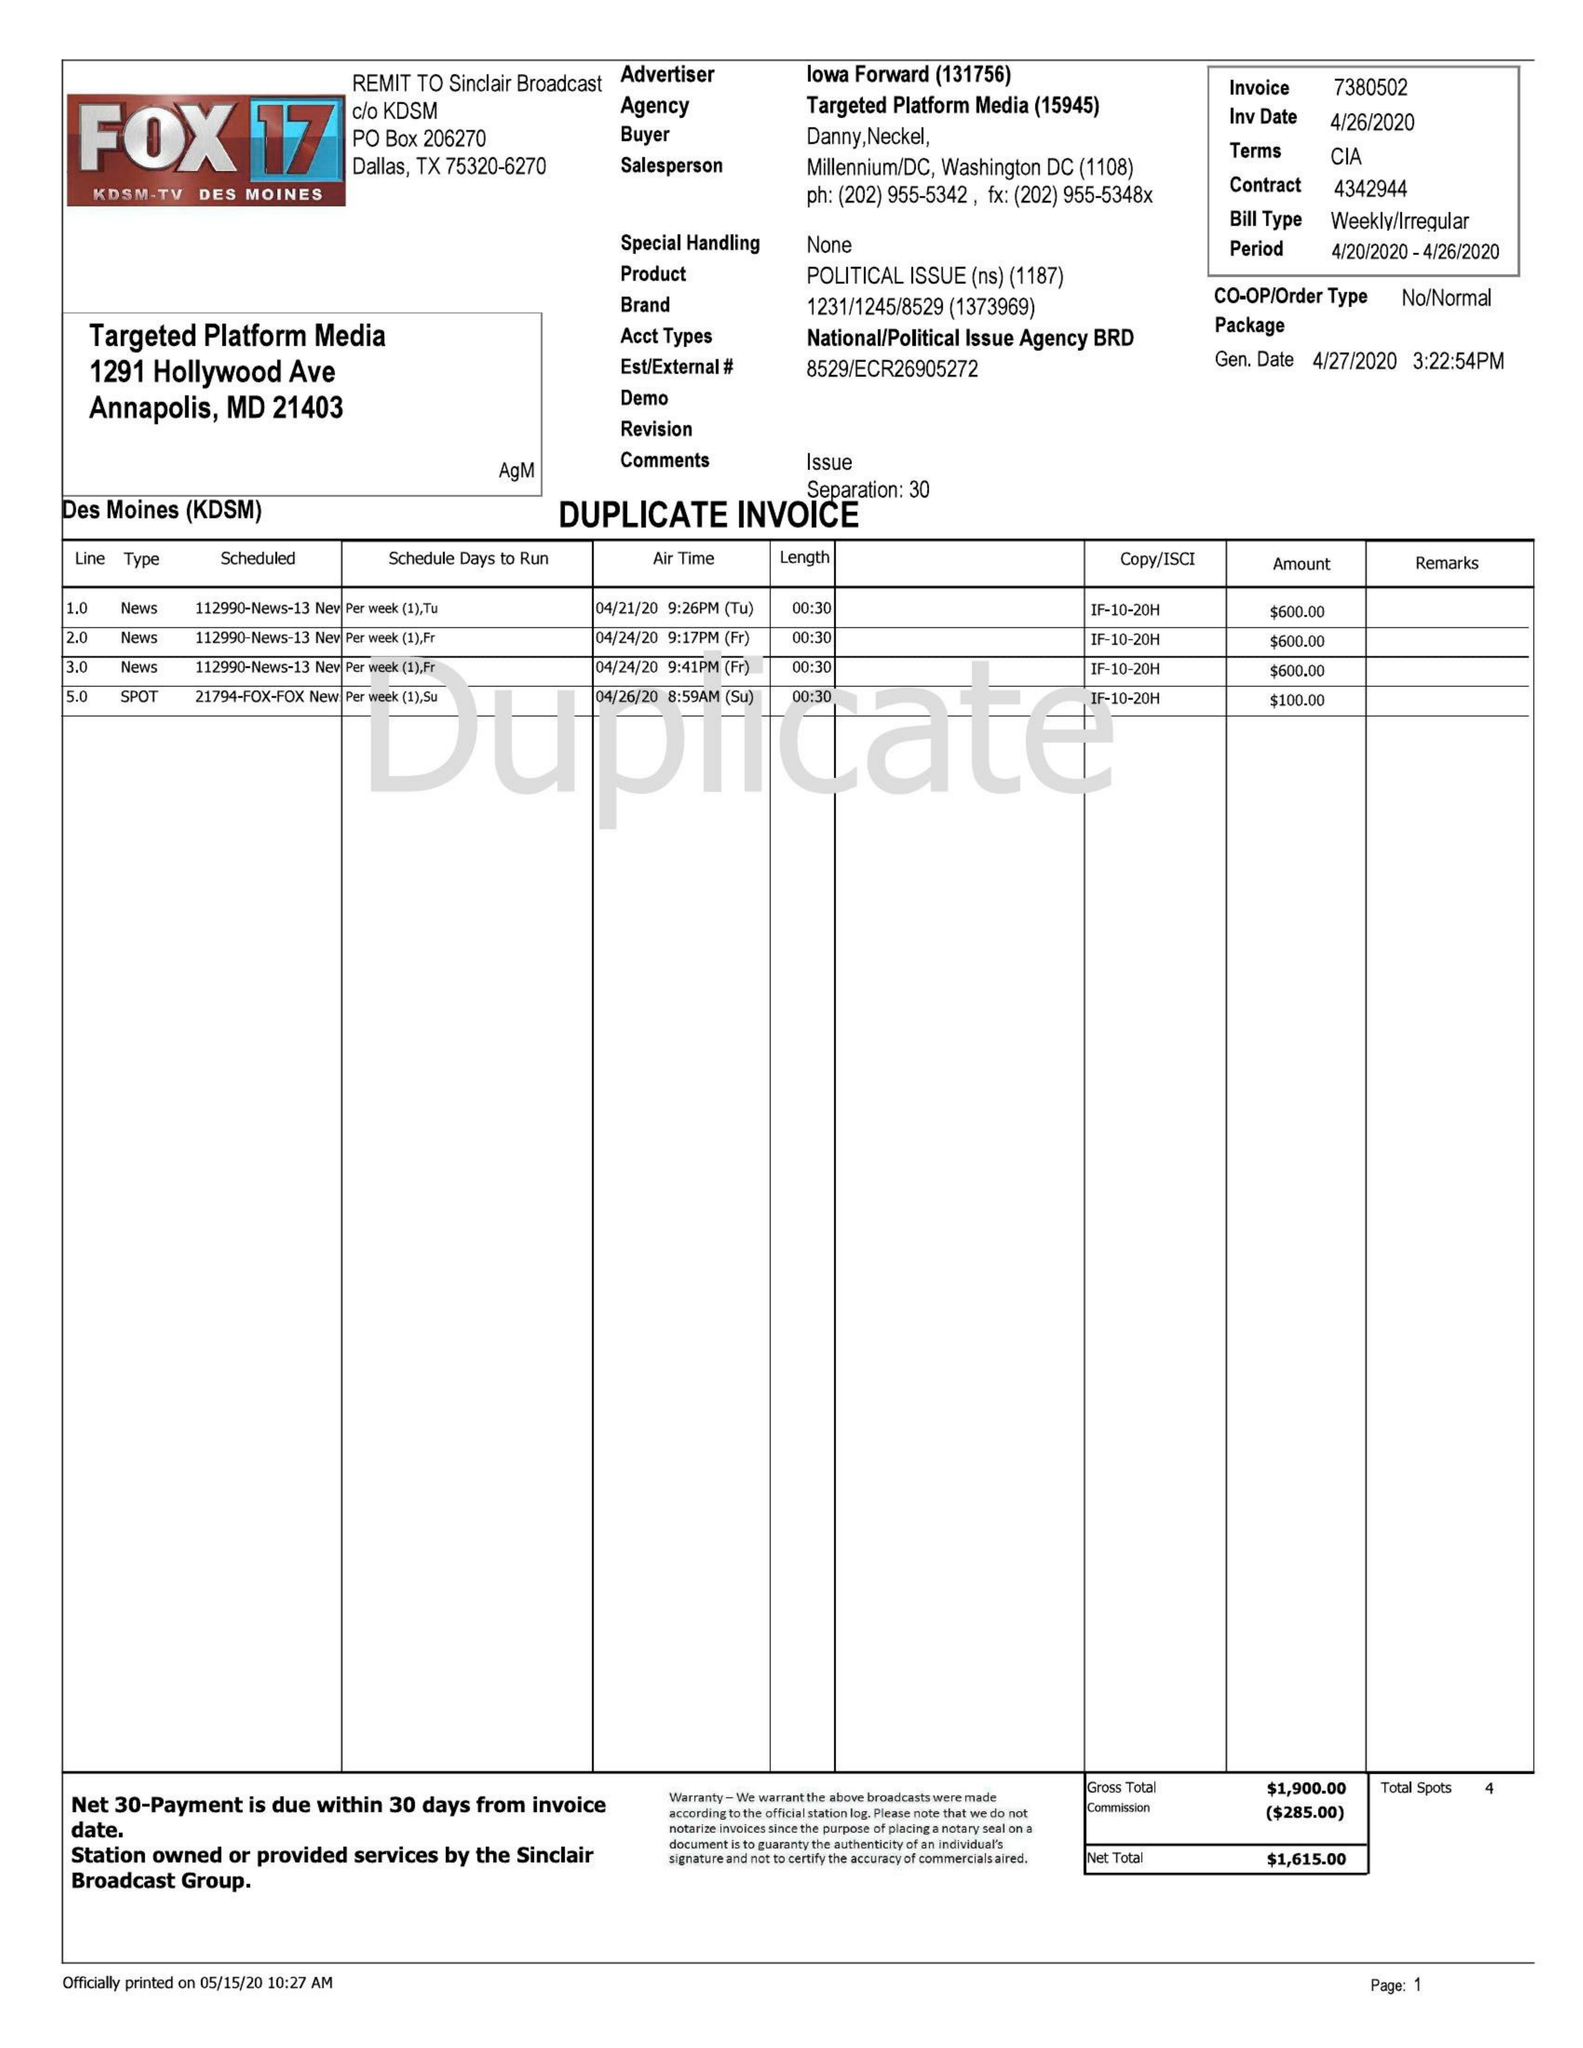What is the value for the gross_amount?
Answer the question using a single word or phrase. 1900.00 